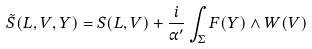<formula> <loc_0><loc_0><loc_500><loc_500>\tilde { S } ( L , V , Y ) = S ( L , V ) + \frac { i } { \alpha ^ { \prime } } \int _ { \Sigma } F ( Y ) \wedge W ( V )</formula> 